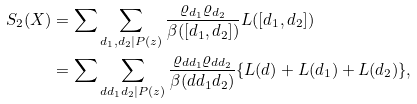Convert formula to latex. <formula><loc_0><loc_0><loc_500><loc_500>S _ { 2 } ( X ) & = \sum \sum _ { d _ { 1 } , d _ { 2 } | P ( z ) } \frac { \varrho _ { d _ { 1 } } \varrho _ { d _ { 2 } } } { \beta ( [ d _ { 1 } , d _ { 2 } ] ) } L ( [ d _ { 1 } , d _ { 2 } ] ) \\ & = \sum \sum _ { d d _ { 1 } d _ { 2 } | P ( z ) } \frac { \varrho _ { d d _ { 1 } } \varrho _ { d d _ { 2 } } } { \beta ( d d _ { 1 } d _ { 2 } ) } \{ L ( d ) + L ( d _ { 1 } ) + L ( d _ { 2 } ) \} ,</formula> 